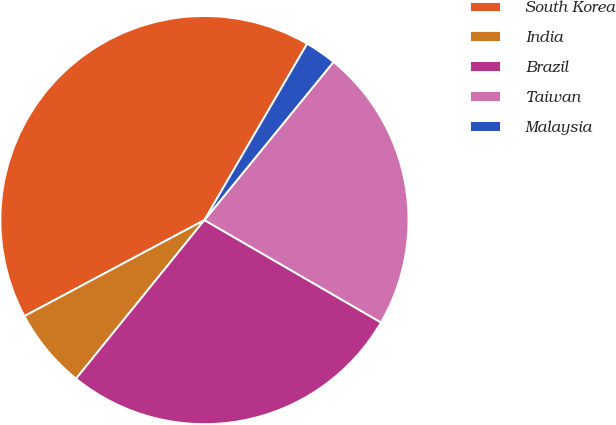Convert chart to OTSL. <chart><loc_0><loc_0><loc_500><loc_500><pie_chart><fcel>South Korea<fcel>India<fcel>Brazil<fcel>Taiwan<fcel>Malaysia<nl><fcel>41.2%<fcel>6.37%<fcel>27.47%<fcel>22.47%<fcel>2.5%<nl></chart> 